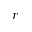Convert formula to latex. <formula><loc_0><loc_0><loc_500><loc_500>r</formula> 